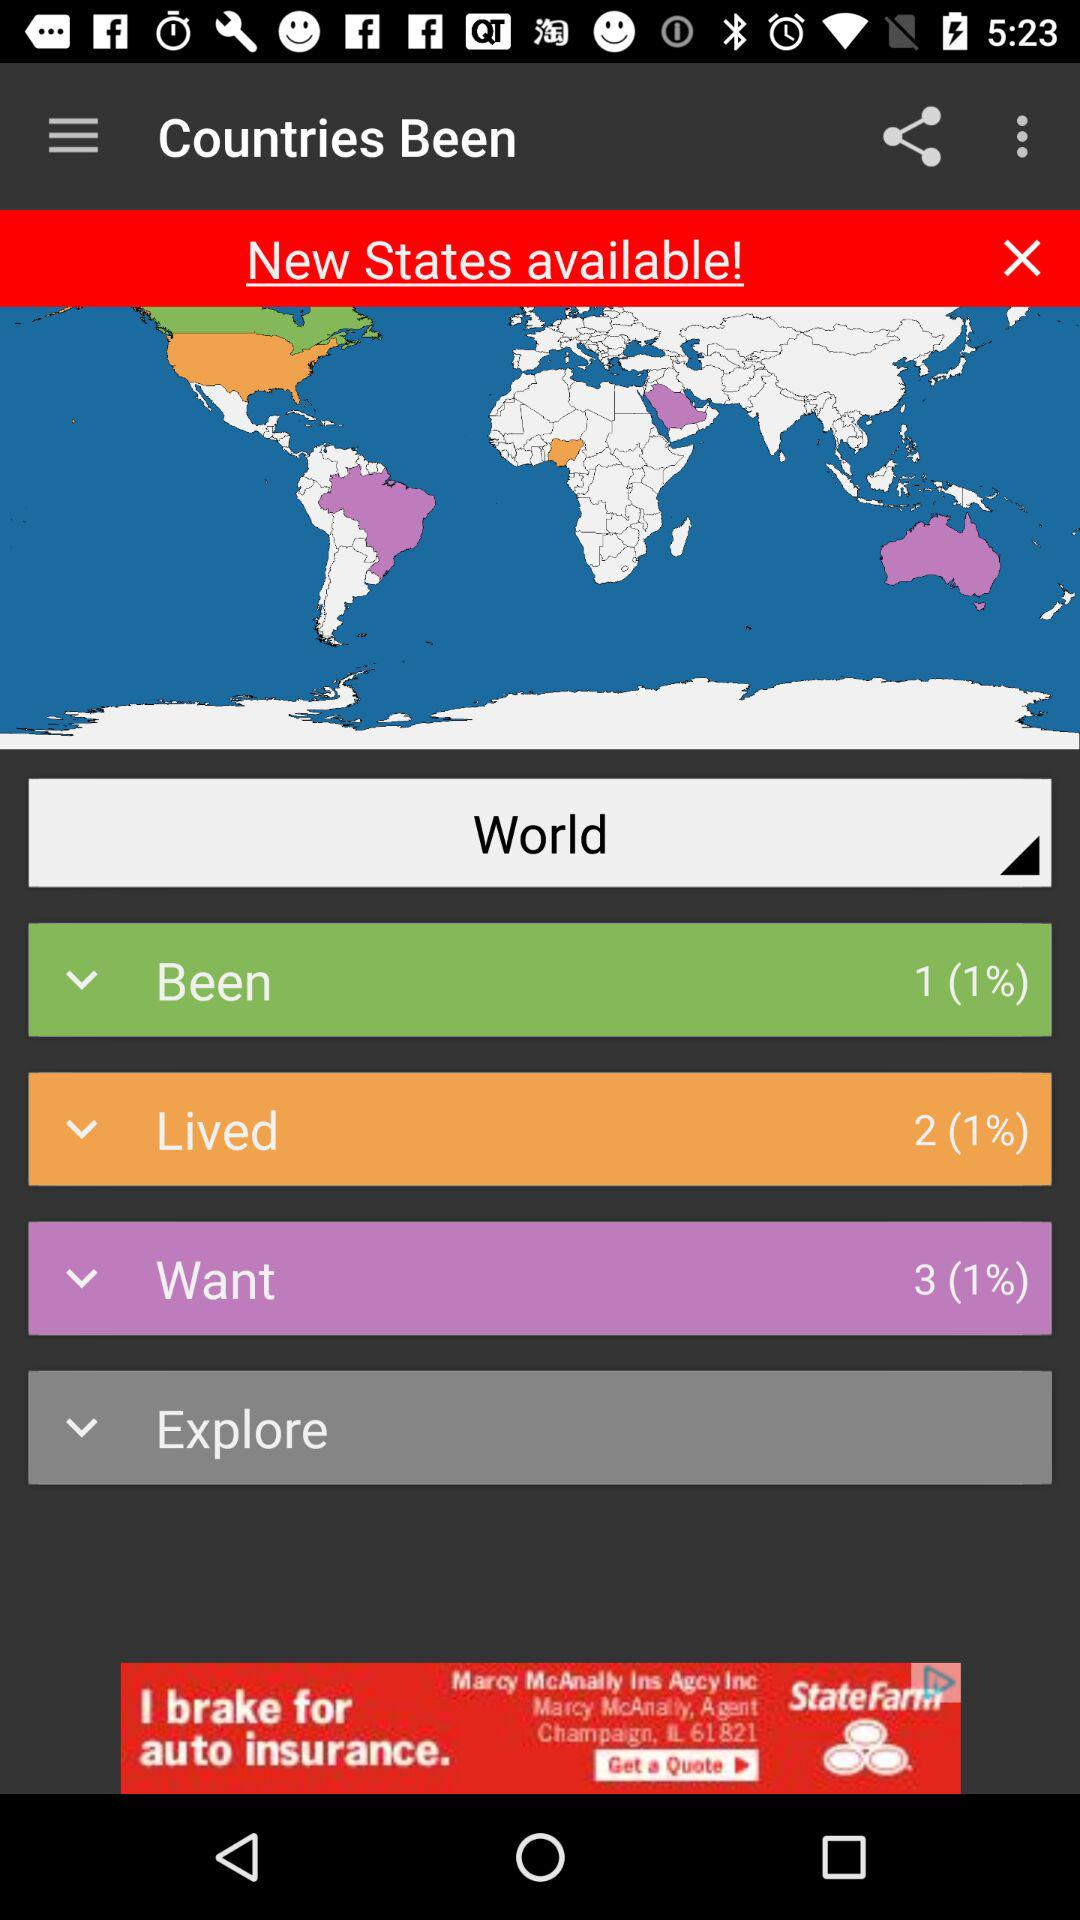What is the percentage of "Want"? The percentage of "Want" is 1. 